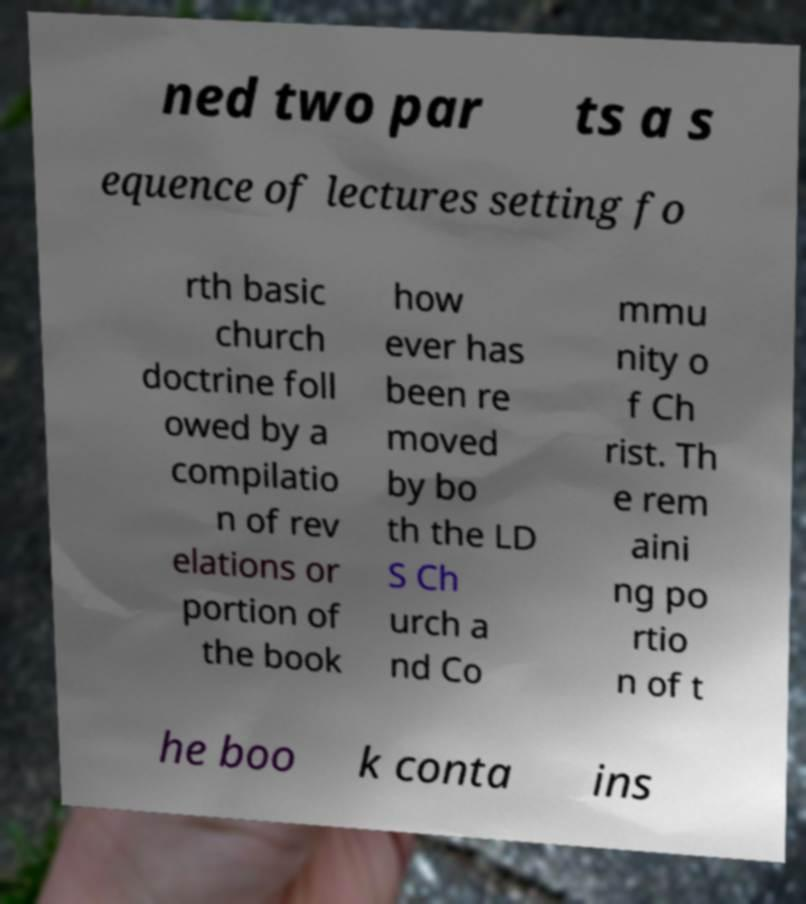What messages or text are displayed in this image? I need them in a readable, typed format. ned two par ts a s equence of lectures setting fo rth basic church doctrine foll owed by a compilatio n of rev elations or portion of the book how ever has been re moved by bo th the LD S Ch urch a nd Co mmu nity o f Ch rist. Th e rem aini ng po rtio n of t he boo k conta ins 